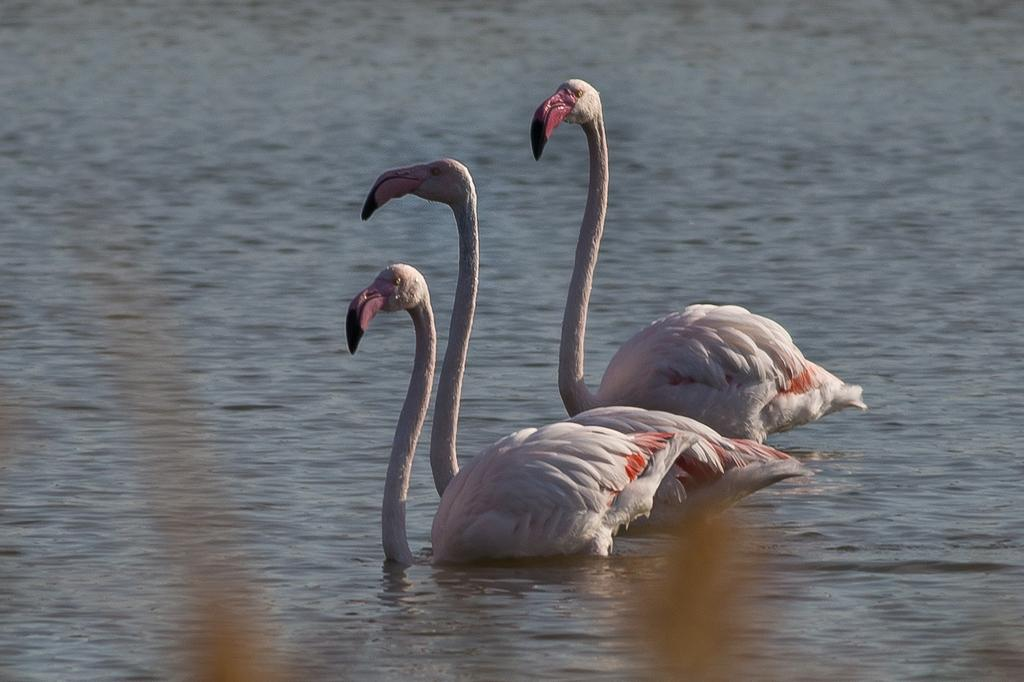How many birds are in the image? There are three birds in the image. Where are the birds located in the image? The birds are in the water. What type of environment might the image depict? The image may have been taken at a lake. What type of holiday is the ghost celebrating in the image? There is no ghost or holiday present in the image; it features three birds in the water. 